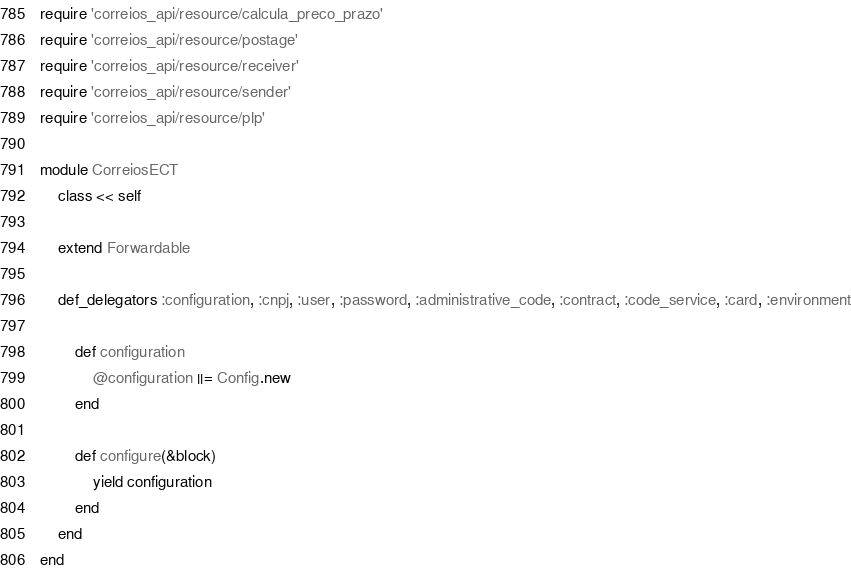<code> <loc_0><loc_0><loc_500><loc_500><_Ruby_>require 'correios_api/resource/calcula_preco_prazo'
require 'correios_api/resource/postage'
require 'correios_api/resource/receiver'
require 'correios_api/resource/sender'
require 'correios_api/resource/plp'

module CorreiosECT
	class << self

    extend Forwardable

    def_delegators :configuration, :cnpj, :user, :password, :administrative_code, :contract, :code_service, :card, :environment

		def configuration
			@configuration ||= Config.new
		end

		def configure(&block)
			yield configuration
		end
	end
end

</code> 